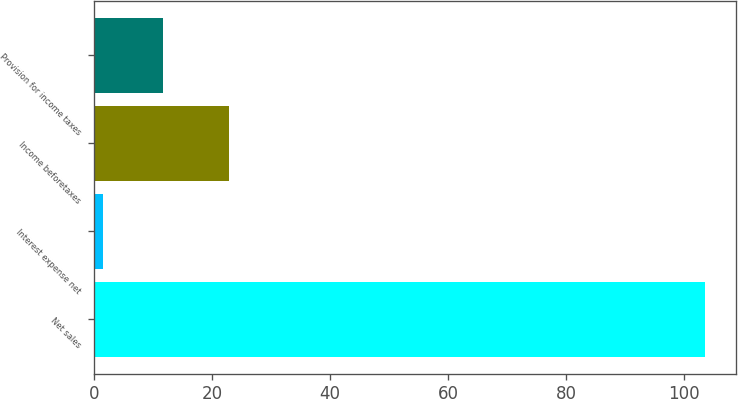Convert chart to OTSL. <chart><loc_0><loc_0><loc_500><loc_500><bar_chart><fcel>Net sales<fcel>Interest expense net<fcel>Income beforetaxes<fcel>Provision for income taxes<nl><fcel>103.6<fcel>1.5<fcel>22.9<fcel>11.71<nl></chart> 